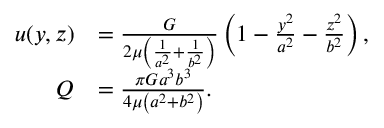Convert formula to latex. <formula><loc_0><loc_0><loc_500><loc_500>{ \begin{array} { r l } { u ( y , z ) } & { = { \frac { G } { 2 \mu \left ( { \frac { 1 } { a ^ { 2 } } } + { \frac { 1 } { b ^ { 2 } } } \right ) } } \left ( 1 - { \frac { y ^ { 2 } } { a ^ { 2 } } } - { \frac { z ^ { 2 } } { b ^ { 2 } } } \right ) , } \\ { Q } & { = { \frac { \pi G a ^ { 3 } b ^ { 3 } } { 4 \mu \left ( a ^ { 2 } + b ^ { 2 } \right ) } } . } \end{array} }</formula> 